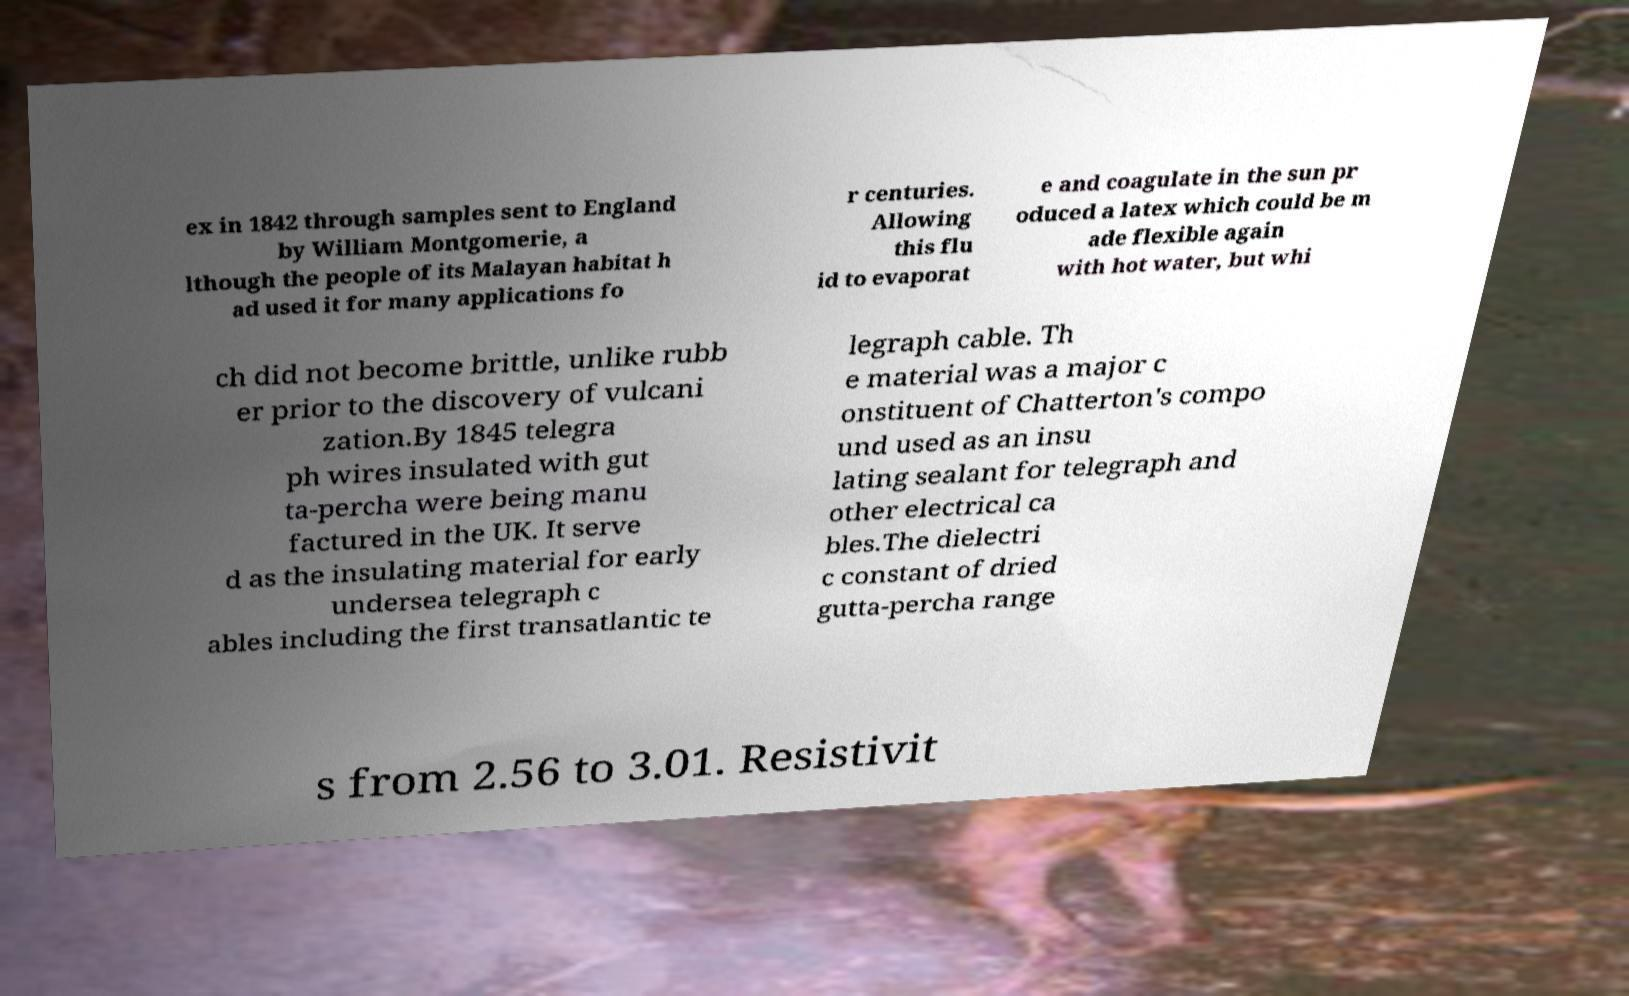Could you assist in decoding the text presented in this image and type it out clearly? ex in 1842 through samples sent to England by William Montgomerie, a lthough the people of its Malayan habitat h ad used it for many applications fo r centuries. Allowing this flu id to evaporat e and coagulate in the sun pr oduced a latex which could be m ade flexible again with hot water, but whi ch did not become brittle, unlike rubb er prior to the discovery of vulcani zation.By 1845 telegra ph wires insulated with gut ta-percha were being manu factured in the UK. It serve d as the insulating material for early undersea telegraph c ables including the first transatlantic te legraph cable. Th e material was a major c onstituent of Chatterton's compo und used as an insu lating sealant for telegraph and other electrical ca bles.The dielectri c constant of dried gutta-percha range s from 2.56 to 3.01. Resistivit 